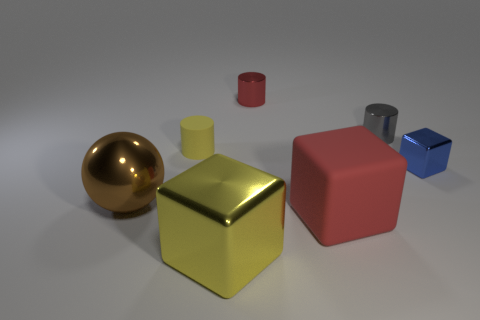Subtract all large rubber cubes. How many cubes are left? 2 Subtract all gray cylinders. How many cylinders are left? 2 Add 3 tiny yellow matte things. How many objects exist? 10 Subtract all balls. How many objects are left? 6 Subtract 2 cylinders. How many cylinders are left? 1 Subtract all gray cylinders. Subtract all gray spheres. How many cylinders are left? 2 Subtract all purple cubes. How many cyan spheres are left? 0 Subtract all red matte blocks. Subtract all yellow rubber cylinders. How many objects are left? 5 Add 6 red objects. How many red objects are left? 8 Add 6 cylinders. How many cylinders exist? 9 